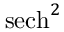<formula> <loc_0><loc_0><loc_500><loc_500>s e c h ^ { 2 }</formula> 